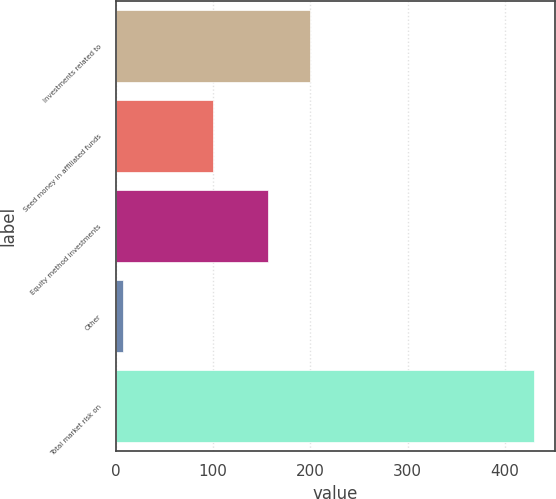<chart> <loc_0><loc_0><loc_500><loc_500><bar_chart><fcel>Investments related to<fcel>Seed money in affiliated funds<fcel>Equity method investments<fcel>Other<fcel>Total market risk on<nl><fcel>199.09<fcel>99.5<fcel>156.9<fcel>7.5<fcel>429.4<nl></chart> 